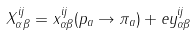<formula> <loc_0><loc_0><loc_500><loc_500>X _ { \alpha \beta } ^ { i j } = x _ { \alpha \beta } ^ { i j } ( p _ { a } \rightarrow \pi _ { a } ) + e y _ { \alpha \beta } ^ { i j }</formula> 